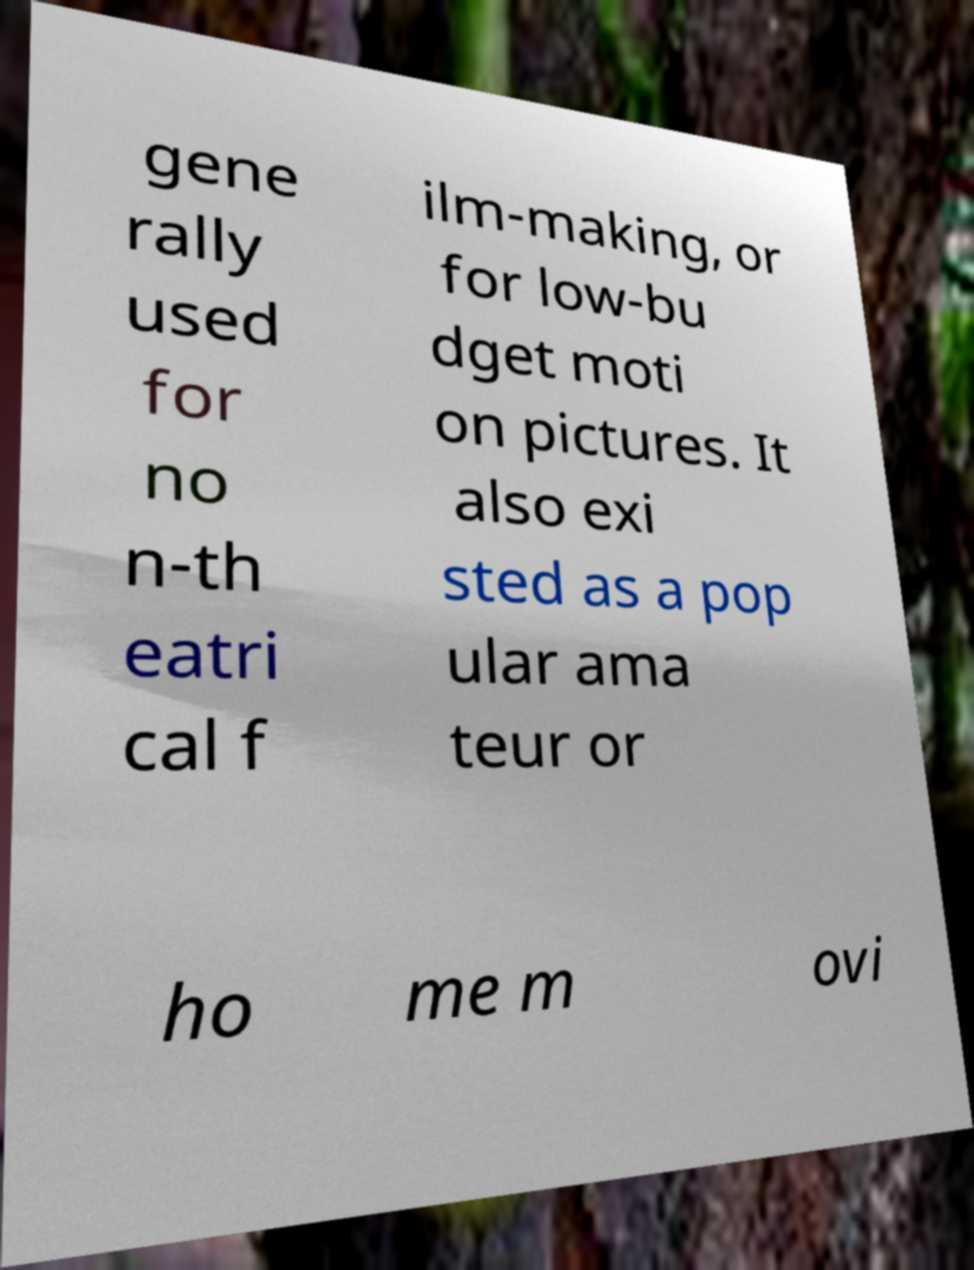Please read and relay the text visible in this image. What does it say? gene rally used for no n-th eatri cal f ilm-making, or for low-bu dget moti on pictures. It also exi sted as a pop ular ama teur or ho me m ovi 